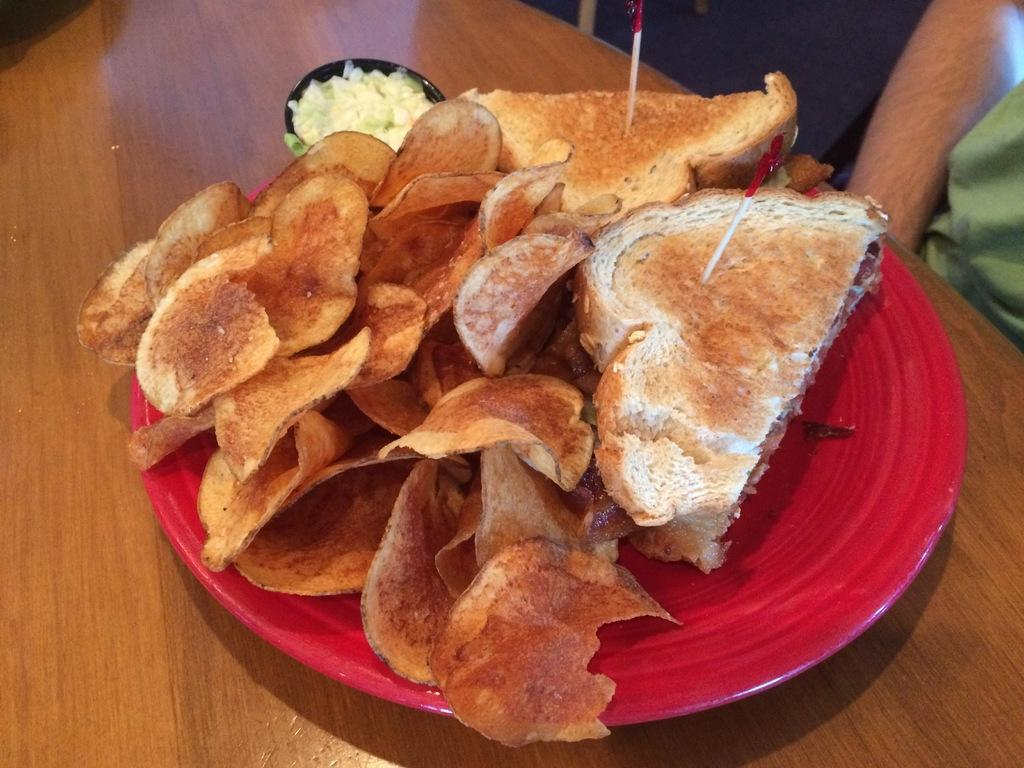What type of food is on the plate in the image? There are chips and sandwiches with toothpicks on the plate in the image. Where is the plate located in the image? The plate is on a table in the image. What can be seen in the background of the image? There is a chair and a person in the background of the image. What type of reward is being given to the person in the image? There is no reward being given in the image; it only shows a plate of food on a table. 